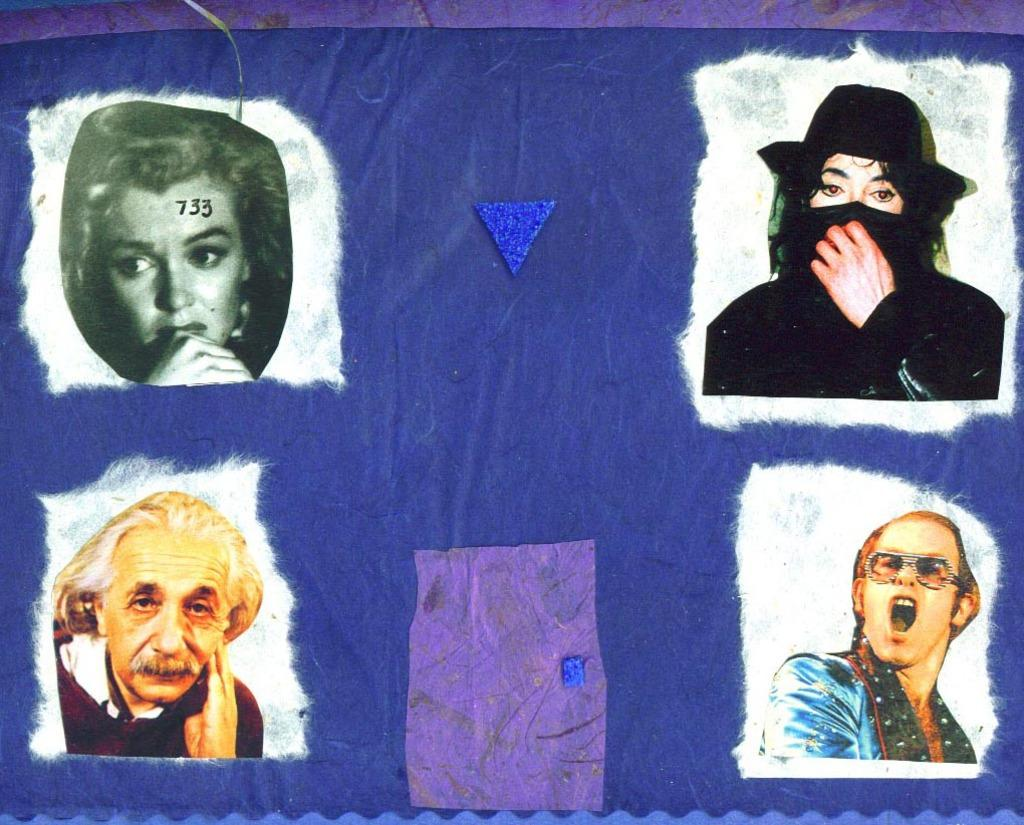What is present in the image that is used for displaying information? There is a banner in the image that is used for displaying information. What types of elements can be found on the banner? The banner contains images, numbers, and objects. What type of lunch is being served on the map in the image? There is no lunch or map present in the image; it only contains a banner with images, numbers, and objects. 